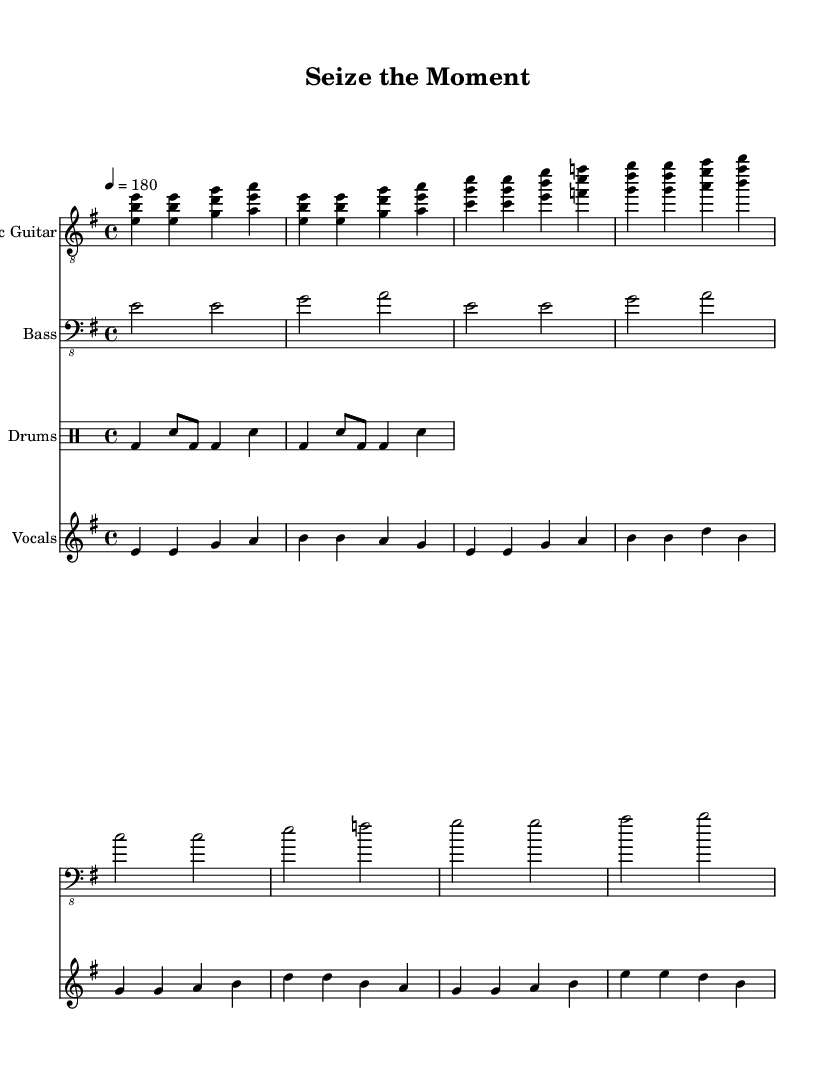What is the key signature of this music? The key signature for this piece is indicated by the "e minor" key, which has one sharp (F#).
Answer: E minor What is the time signature of this music? The time signature is displayed at the beginning of the score as 4/4, indicating four beats in each measure.
Answer: 4/4 What is the tempo marking given? The tempo marking indicates the piece should be played at a speed of 180 beats per minute, signified by "4 = 180".
Answer: 180 How many measures does the vocal part contain in the verse? The verse of the vocals has four measures as indicated by the grouped lines in the vocal staff.
Answer: Four Which instrument is playing the electric guitar part? The instrument designated for the melody line at the top of the score is labeled as "Electric Guitar".
Answer: Electric Guitar What is the main theme of the chorus lyrics? The chorus lyrics state the empowerment message that epilepsy will not define individuals, emphasizing strength and resilience against silence.
Answer: Empowerment against epilepsy What rhythm pattern is indicated in the drum section? The drum pattern consists of a combination of bass and snare hits, creating an upbeat driving rhythm common in punk music.
Answer: Bass and snare rhythm 